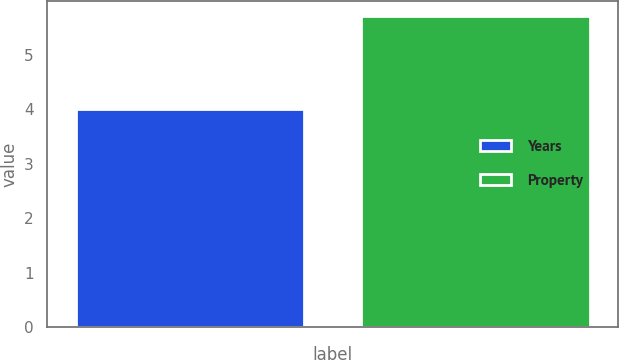<chart> <loc_0><loc_0><loc_500><loc_500><bar_chart><fcel>Years<fcel>Property<nl><fcel>4<fcel>5.7<nl></chart> 